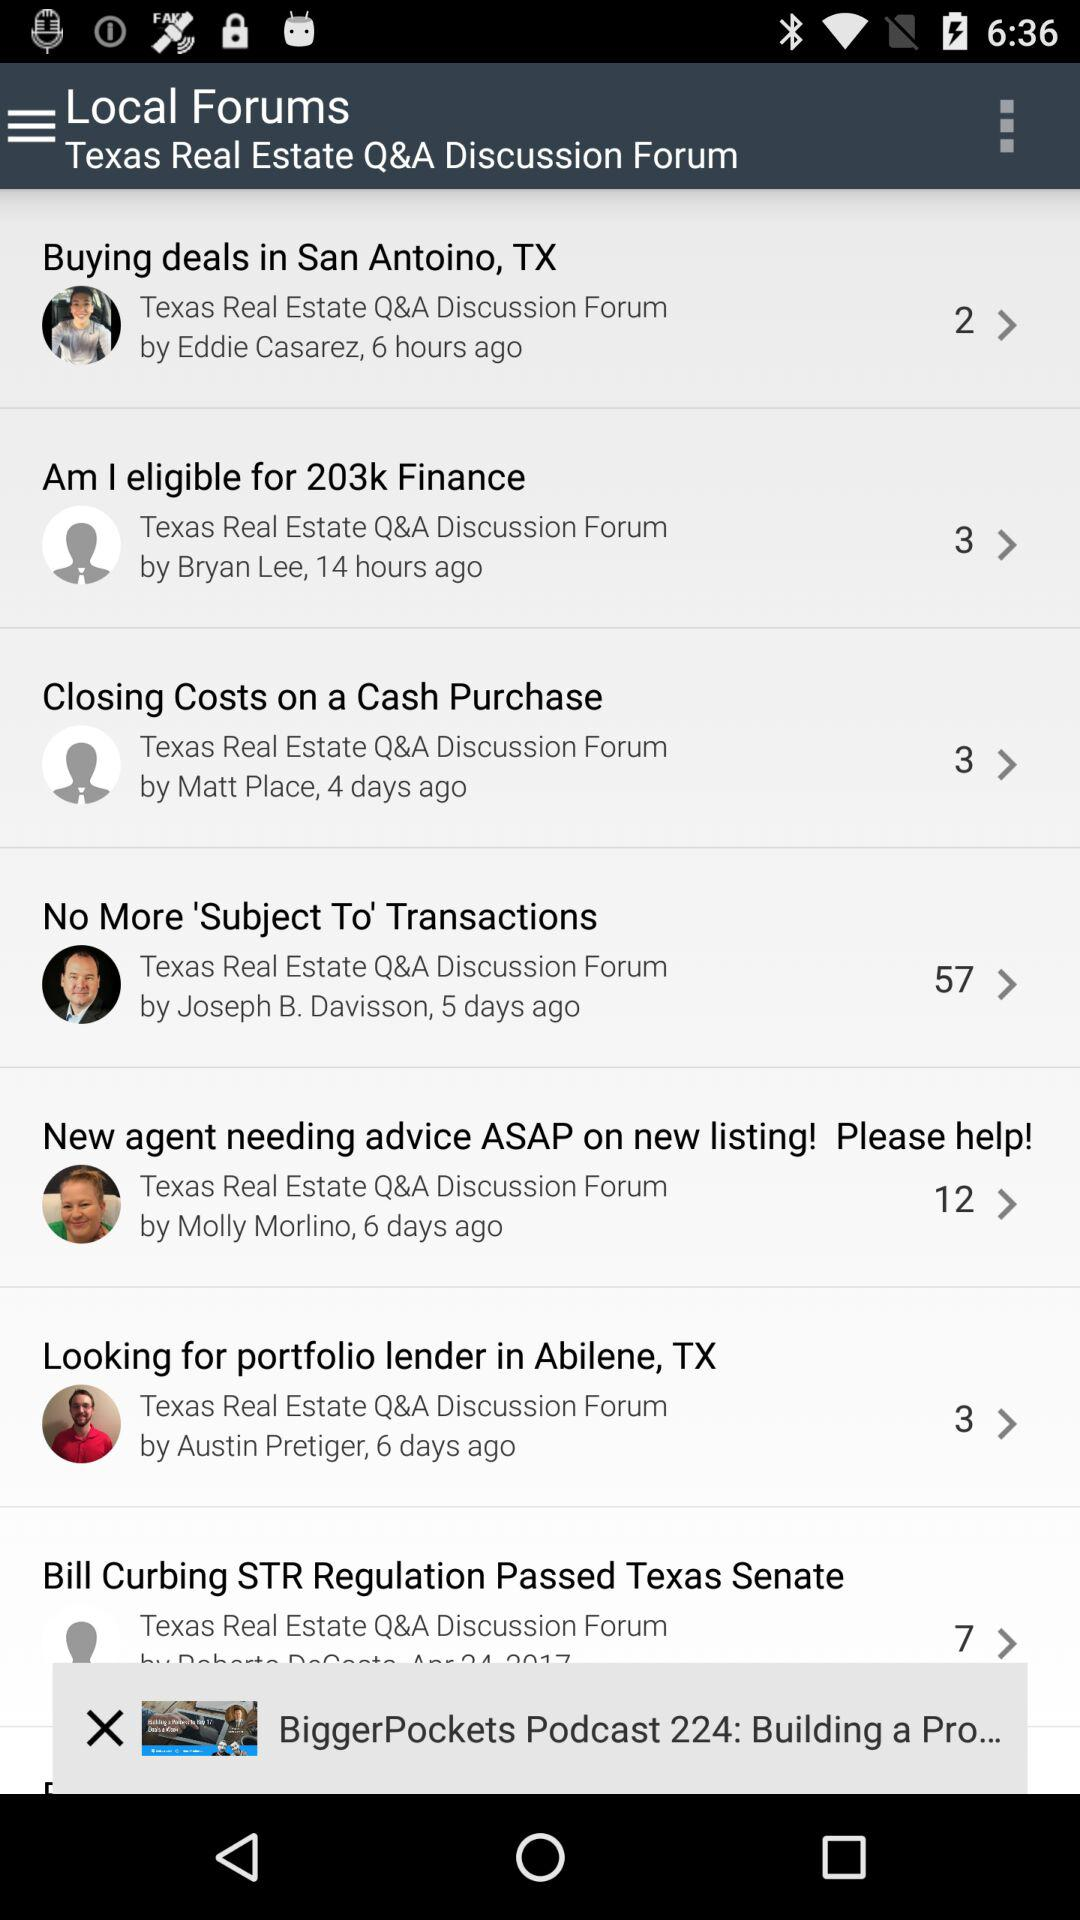What is the application's name?
When the provided information is insufficient, respond with <no answer>. <no answer> 